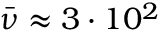Convert formula to latex. <formula><loc_0><loc_0><loc_500><loc_500>\ B a r { \nu } \approx 3 \cdot 1 0 ^ { 2 }</formula> 